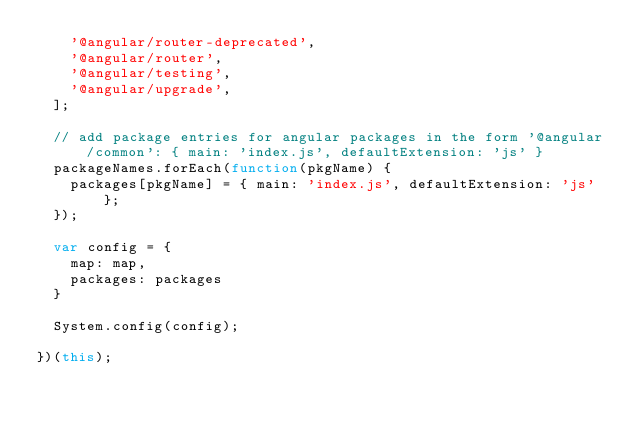Convert code to text. <code><loc_0><loc_0><loc_500><loc_500><_JavaScript_>    '@angular/router-deprecated',
    '@angular/router',
    '@angular/testing',
    '@angular/upgrade',
  ];

  // add package entries for angular packages in the form '@angular/common': { main: 'index.js', defaultExtension: 'js' }
  packageNames.forEach(function(pkgName) {
    packages[pkgName] = { main: 'index.js', defaultExtension: 'js' };
  });

  var config = {
    map: map,
    packages: packages
  }

  System.config(config);

})(this);</code> 